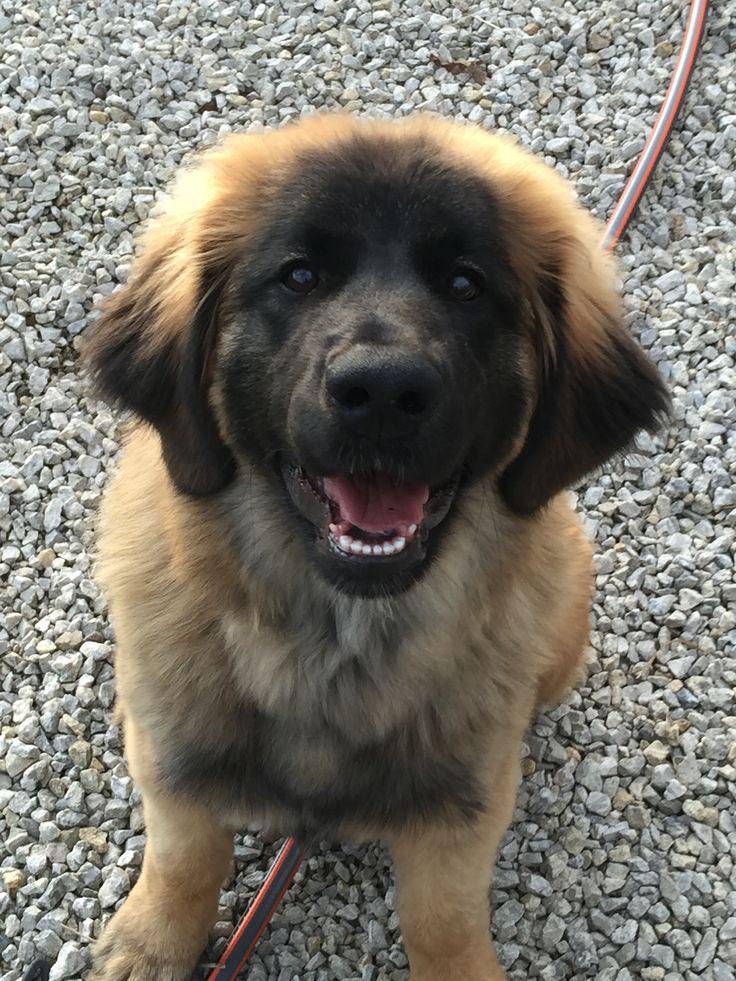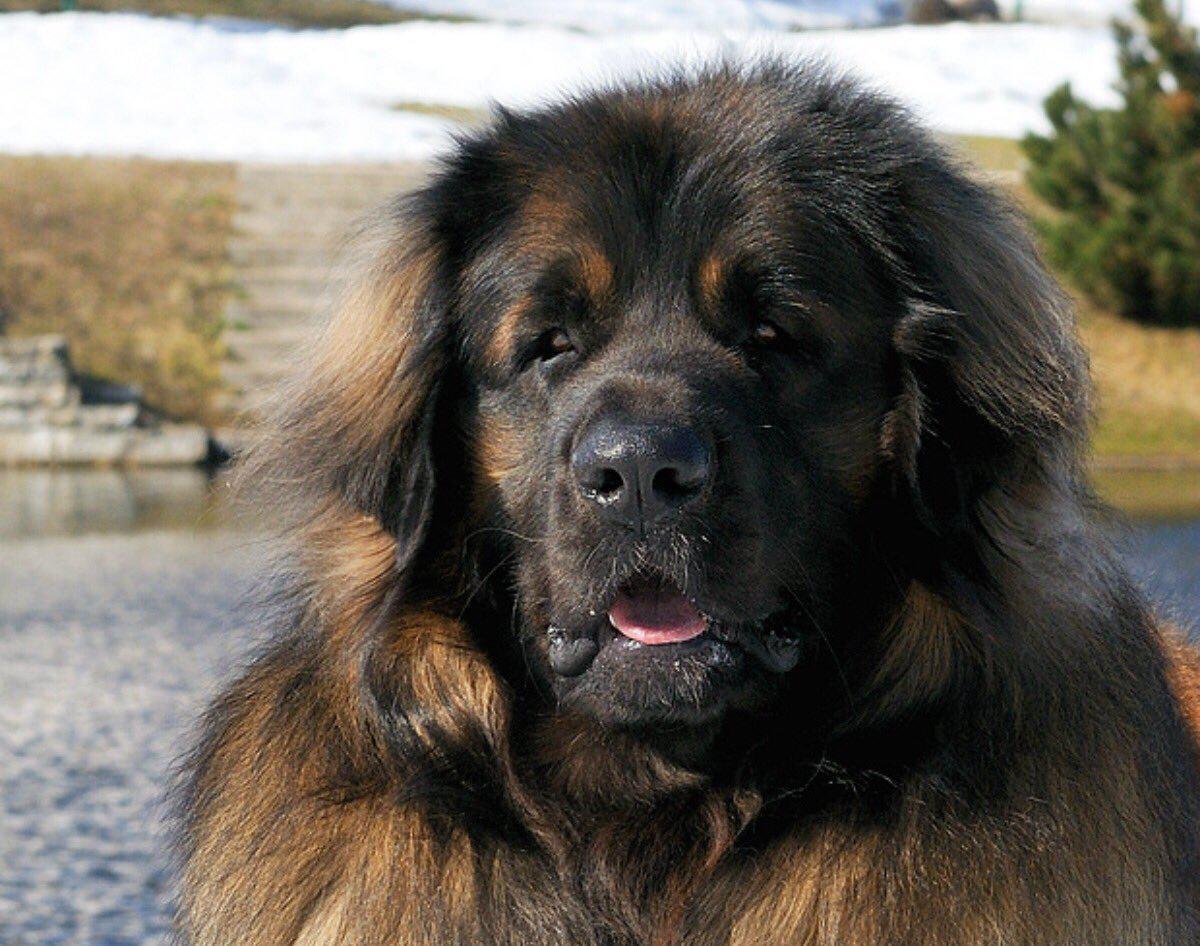The first image is the image on the left, the second image is the image on the right. Considering the images on both sides, is "One image in the pair is an outdoor scene, while the other is clearly indoors." valid? Answer yes or no. No. The first image is the image on the left, the second image is the image on the right. Examine the images to the left and right. Is the description "dogs are in a house" accurate? Answer yes or no. No. 